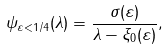Convert formula to latex. <formula><loc_0><loc_0><loc_500><loc_500>\psi _ { \varepsilon < 1 / 4 } ( \lambda ) = \frac { \sigma ( \varepsilon ) } { \lambda - \xi _ { 0 } ( \varepsilon ) } ,</formula> 